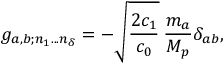Convert formula to latex. <formula><loc_0><loc_0><loc_500><loc_500>g _ { a , b ; n _ { 1 } \dots n _ { \delta } } = - \sqrt { \frac { 2 c _ { 1 } } { c _ { 0 } } } \, \frac { m _ { a } } { M _ { p } } \delta _ { a b } ,</formula> 